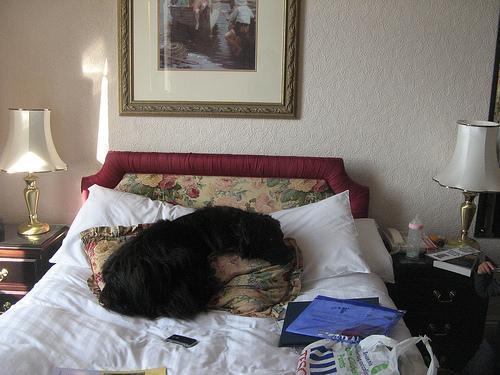How many lamps are there?
Give a very brief answer. 2. 